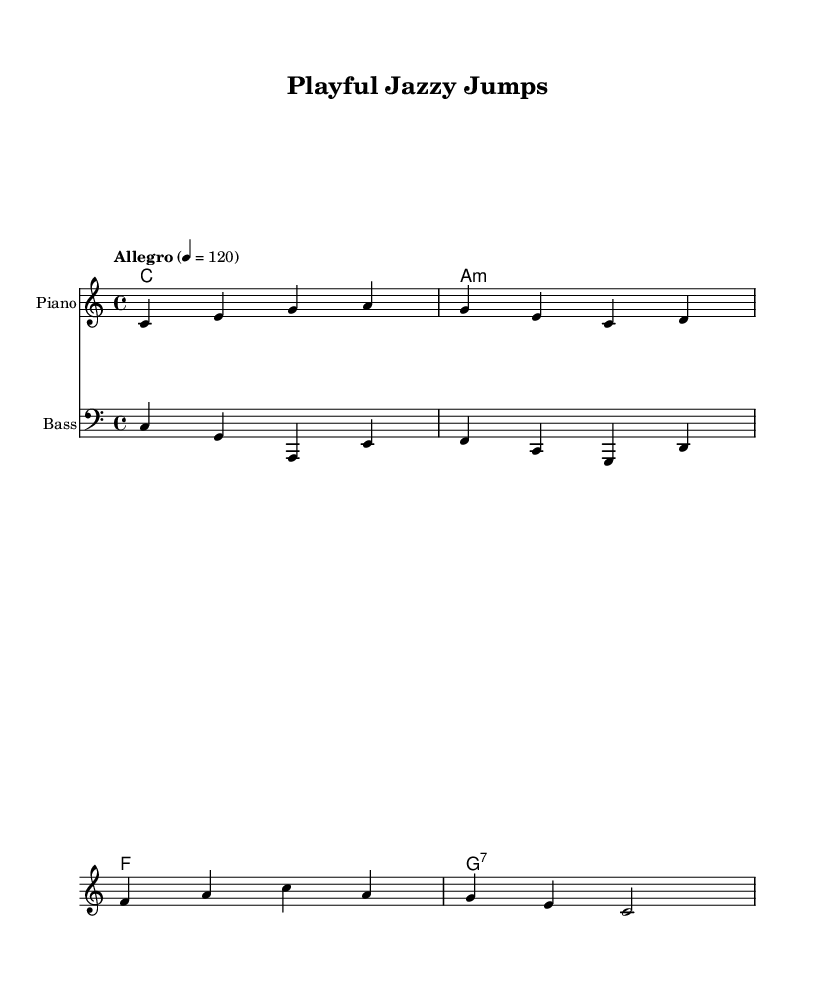What is the key signature of this music? The key signature indicated is C major, which has no sharps or flats. The 'c' note indicates the tonic of C major.
Answer: C major What is the time signature of the piece? The time signature shown is 4/4, meaning there are four beats in each measure and the quarter note gets one beat.
Answer: 4/4 What is the tempo marking of the piece? The tempo marking is "Allegro" with a metronome marking of 120 beats per minute, suggesting a fast and lively pace for the piece.
Answer: Allegro 120 How many measures are in the melody? By counting the bar lines in the melody, there are four measures total in the provided melodic line.
Answer: Four measures Which chord appears first in the harmony? The first chord in the harmony section is C major, represented by the single note 'c' and no additional symbols indicating any changes.
Answer: C major What is the instrument primarily featured in this sheet music? The primary instrument featured is the piano, indicated by the staff label in the score.
Answer: Piano What type of music is this piece categorized as? This piece is categorized as jazz, which is recognized by its playful melody and upbeat rhythm suitable for children's activities.
Answer: Jazz 